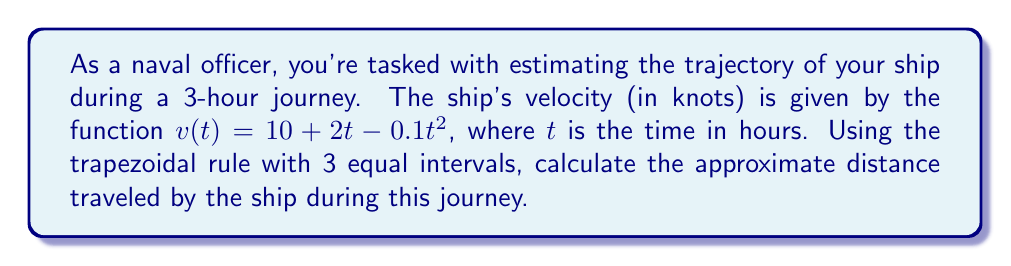Provide a solution to this math problem. To solve this problem, we'll use the trapezoidal rule for numerical integration. The steps are as follows:

1) The distance traveled is the integral of velocity over time. We need to approximate:

   $$\int_0^3 v(t) dt = \int_0^3 (10 + 2t - 0.1t^2) dt$$

2) The trapezoidal rule with n intervals is given by:

   $$\int_a^b f(x) dx \approx \frac{h}{2}[f(x_0) + 2f(x_1) + 2f(x_2) + ... + 2f(x_{n-1}) + f(x_n)]$$

   where $h = \frac{b-a}{n}$ and $x_i = a + ih$

3) We have 3 intervals, so $n = 3$ and $h = \frac{3-0}{3} = 1$

4) We need to calculate $v(t)$ at $t = 0, 1, 2, 3$:

   $v(0) = 10 + 2(0) - 0.1(0)^2 = 10$
   $v(1) = 10 + 2(1) - 0.1(1)^2 = 11.9$
   $v(2) = 10 + 2(2) - 0.1(2)^2 = 13.6$
   $v(3) = 10 + 2(3) - 0.1(3)^2 = 15.1$

5) Applying the trapezoidal rule:

   $$\text{Distance} \approx \frac{1}{2}[10 + 2(11.9) + 2(13.6) + 15.1]$$

6) Calculating:

   $$\text{Distance} \approx \frac{1}{2}[10 + 23.8 + 27.2 + 15.1] = \frac{76.1}{2} = 38.05$$

Therefore, the approximate distance traveled by the ship is 38.05 nautical miles.
Answer: 38.05 nautical miles 